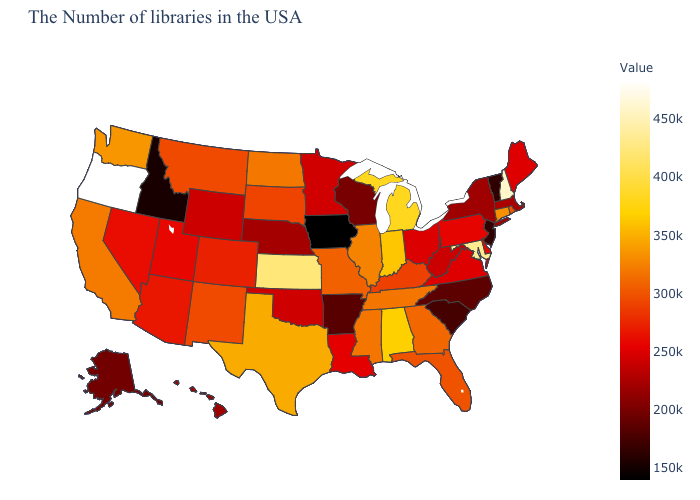Is the legend a continuous bar?
Short answer required. Yes. Which states have the lowest value in the USA?
Quick response, please. Iowa. Does Wisconsin have the lowest value in the USA?
Quick response, please. No. Does Oregon have the highest value in the USA?
Write a very short answer. Yes. Which states hav the highest value in the Northeast?
Be succinct. New Hampshire. Does Nevada have the lowest value in the West?
Concise answer only. No. 